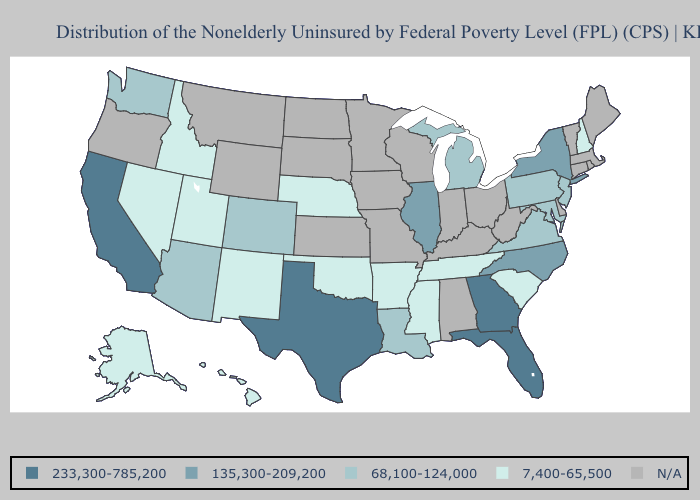What is the lowest value in the USA?
Answer briefly. 7,400-65,500. Name the states that have a value in the range 233,300-785,200?
Give a very brief answer. California, Florida, Georgia, Texas. Among the states that border California , does Arizona have the lowest value?
Short answer required. No. Name the states that have a value in the range N/A?
Keep it brief. Alabama, Connecticut, Delaware, Indiana, Iowa, Kansas, Kentucky, Maine, Massachusetts, Minnesota, Missouri, Montana, North Dakota, Ohio, Oregon, Rhode Island, South Dakota, Vermont, West Virginia, Wisconsin, Wyoming. Does Mississippi have the lowest value in the USA?
Write a very short answer. Yes. Does Texas have the lowest value in the South?
Write a very short answer. No. What is the value of Wyoming?
Answer briefly. N/A. What is the value of Idaho?
Write a very short answer. 7,400-65,500. Does Georgia have the highest value in the USA?
Keep it brief. Yes. What is the value of Nebraska?
Give a very brief answer. 7,400-65,500. What is the lowest value in states that border Mississippi?
Concise answer only. 7,400-65,500. Is the legend a continuous bar?
Concise answer only. No. Name the states that have a value in the range 233,300-785,200?
Write a very short answer. California, Florida, Georgia, Texas. Is the legend a continuous bar?
Give a very brief answer. No. Which states have the highest value in the USA?
Quick response, please. California, Florida, Georgia, Texas. 